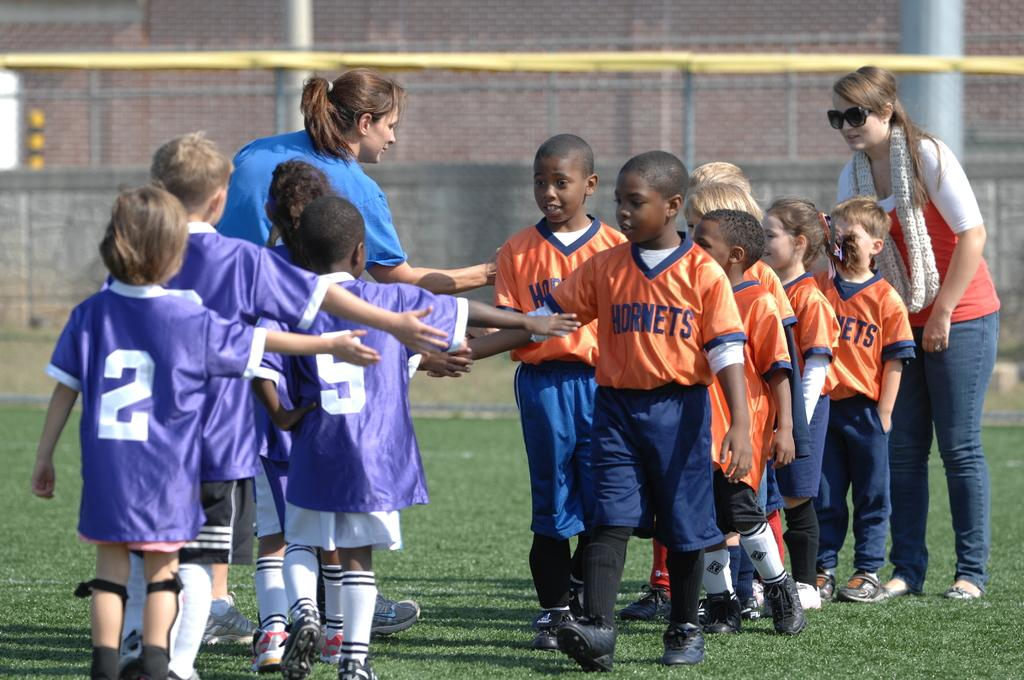What is the setting of the image? Children are standing in a ground. What are the children wearing? The children are wearing blue and orange t-shirts. Are there any adults present with the children? Yes, there are 2 women present with the children. What can be seen in the background of the image? There are buildings visible in the background. What type of dock can be seen in the image? There is no dock present in the image. How many hours are the children playing in the image? The image does not provide information about the duration of the children's playtime. 